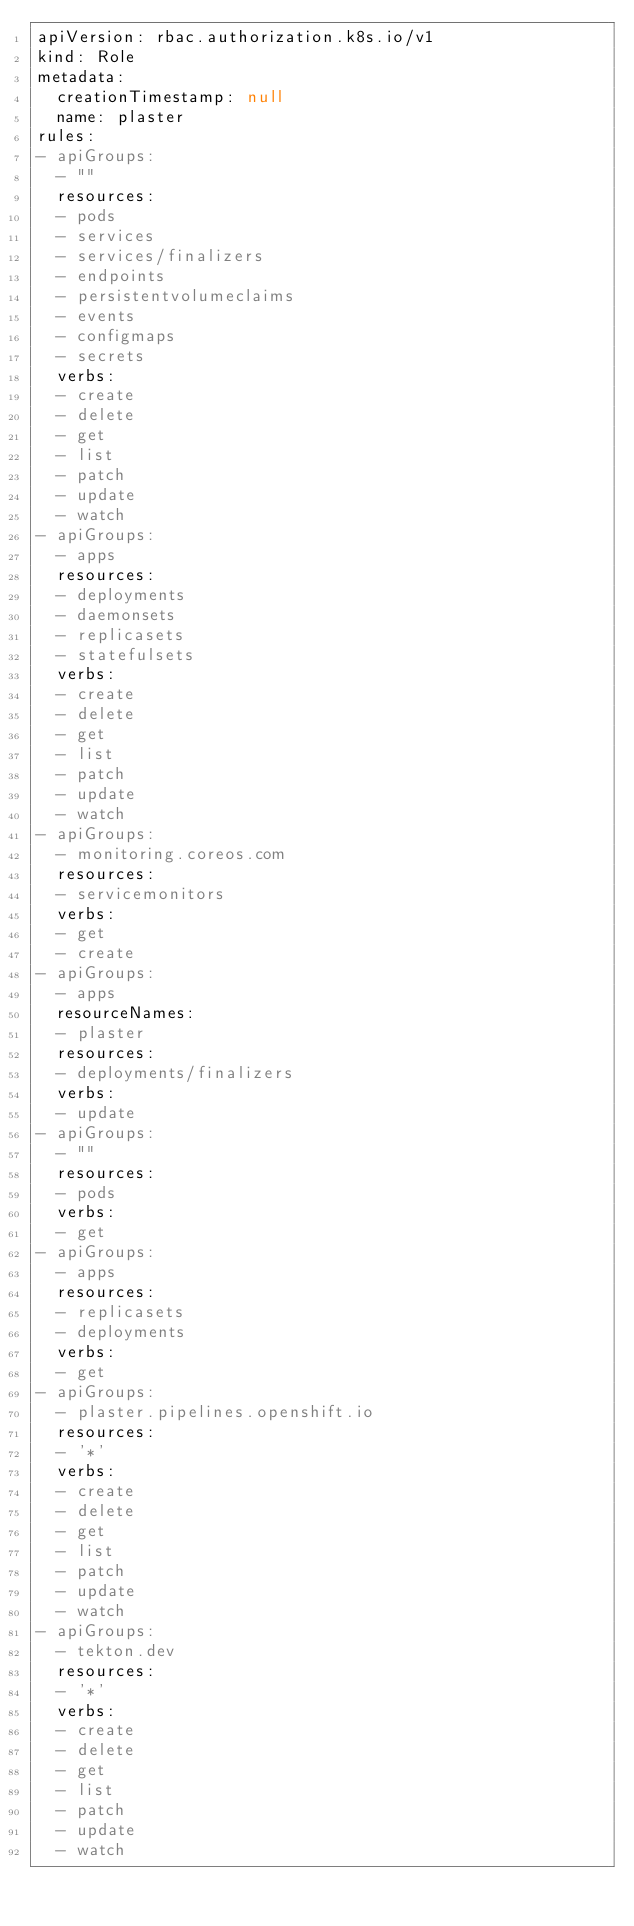<code> <loc_0><loc_0><loc_500><loc_500><_YAML_>apiVersion: rbac.authorization.k8s.io/v1
kind: Role
metadata:
  creationTimestamp: null
  name: plaster
rules:
- apiGroups:
  - ""
  resources:
  - pods
  - services
  - services/finalizers
  - endpoints
  - persistentvolumeclaims
  - events
  - configmaps
  - secrets
  verbs:
  - create
  - delete
  - get
  - list
  - patch
  - update
  - watch
- apiGroups:
  - apps
  resources:
  - deployments
  - daemonsets
  - replicasets
  - statefulsets
  verbs:
  - create
  - delete
  - get
  - list
  - patch
  - update
  - watch
- apiGroups:
  - monitoring.coreos.com
  resources:
  - servicemonitors
  verbs:
  - get
  - create
- apiGroups:
  - apps
  resourceNames:
  - plaster
  resources:
  - deployments/finalizers
  verbs:
  - update
- apiGroups:
  - ""
  resources:
  - pods
  verbs:
  - get
- apiGroups:
  - apps
  resources:
  - replicasets
  - deployments
  verbs:
  - get
- apiGroups:
  - plaster.pipelines.openshift.io
  resources:
  - '*'
  verbs:
  - create
  - delete
  - get
  - list
  - patch
  - update
  - watch
- apiGroups:
  - tekton.dev
  resources:
  - '*'
  verbs:
  - create
  - delete
  - get
  - list
  - patch
  - update
  - watch
</code> 